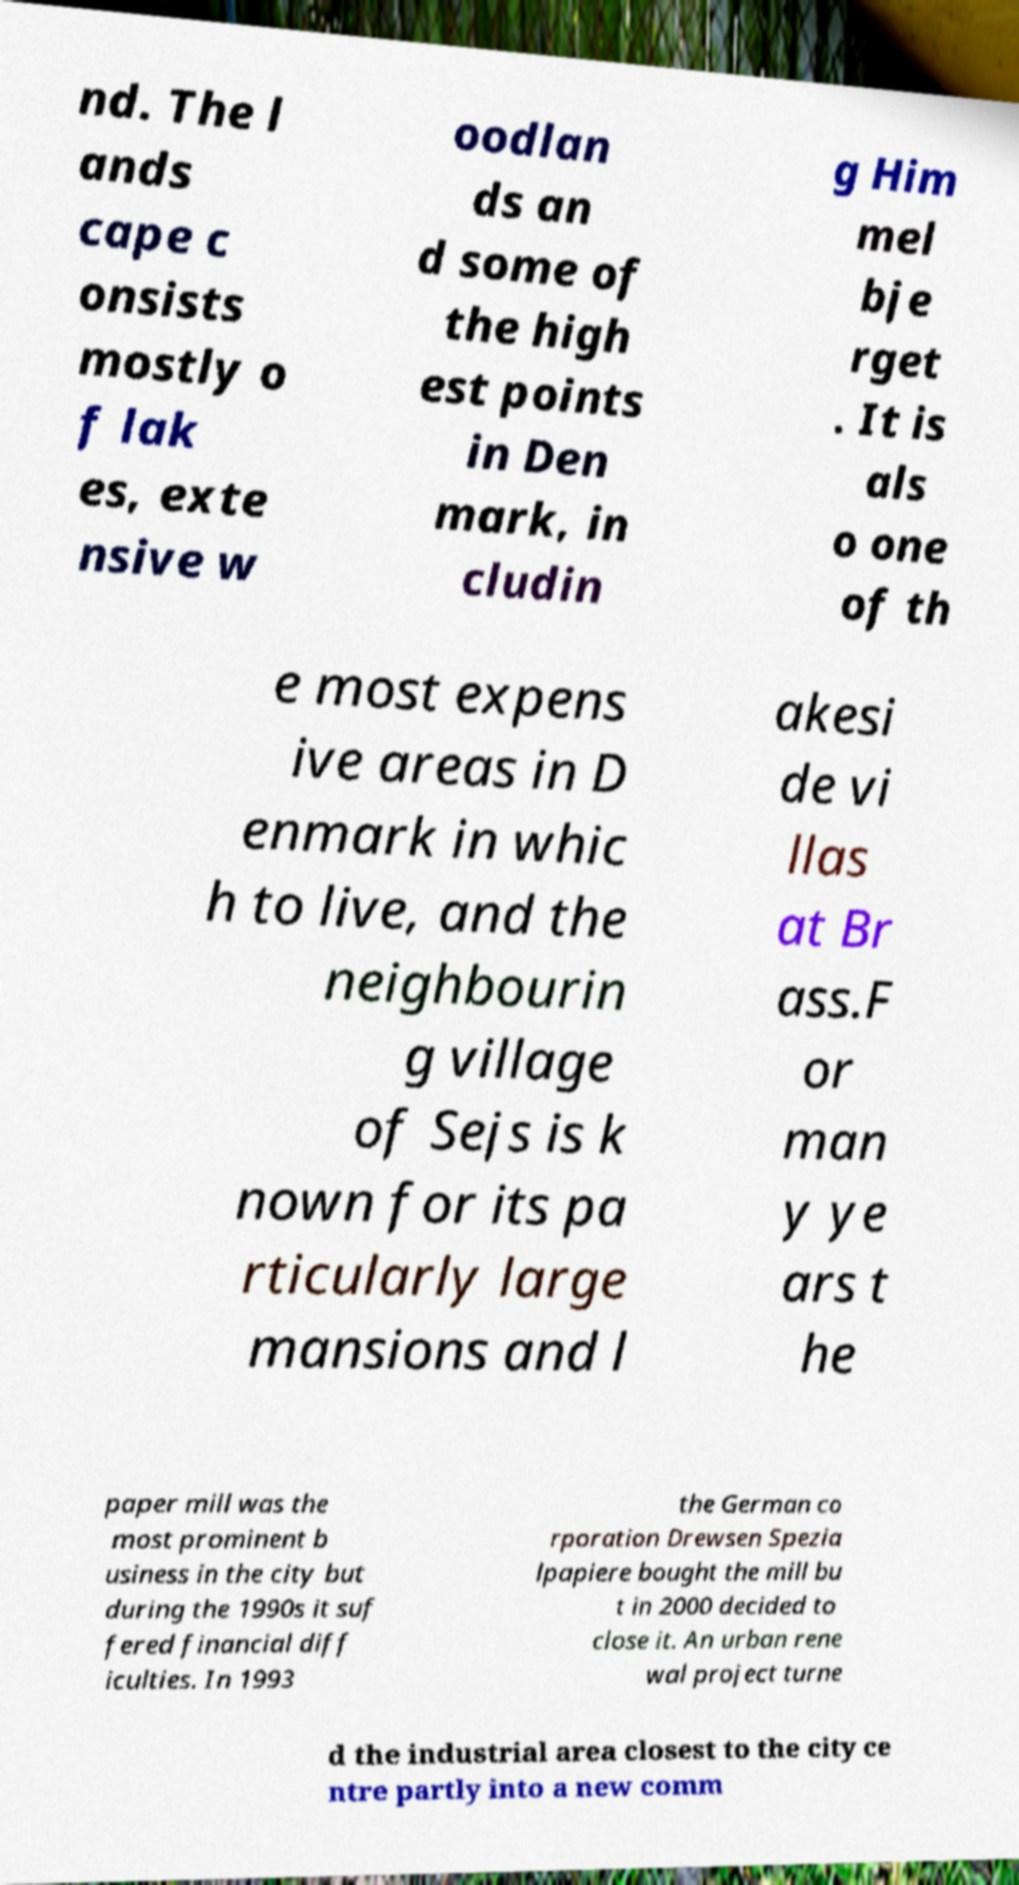Could you assist in decoding the text presented in this image and type it out clearly? nd. The l ands cape c onsists mostly o f lak es, exte nsive w oodlan ds an d some of the high est points in Den mark, in cludin g Him mel bje rget . It is als o one of th e most expens ive areas in D enmark in whic h to live, and the neighbourin g village of Sejs is k nown for its pa rticularly large mansions and l akesi de vi llas at Br ass.F or man y ye ars t he paper mill was the most prominent b usiness in the city but during the 1990s it suf fered financial diff iculties. In 1993 the German co rporation Drewsen Spezia lpapiere bought the mill bu t in 2000 decided to close it. An urban rene wal project turne d the industrial area closest to the city ce ntre partly into a new comm 